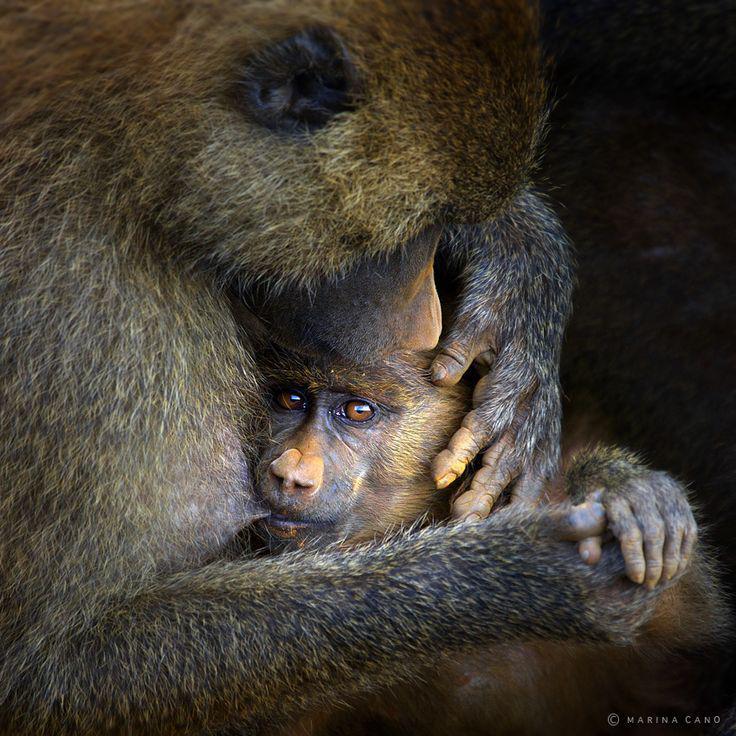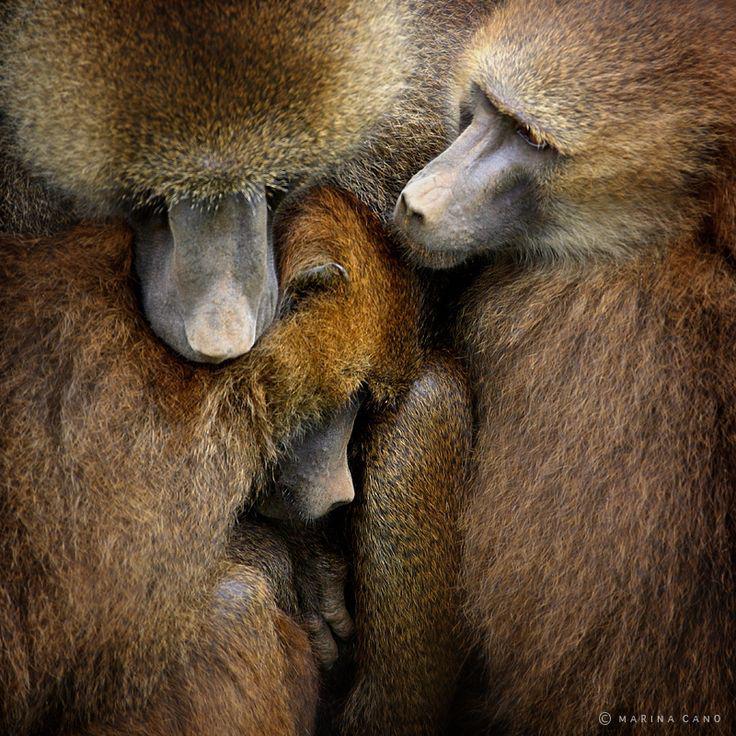The first image is the image on the left, the second image is the image on the right. Examine the images to the left and right. Is the description "At least one monkey has its mouth wide open with sharp teeth visible." accurate? Answer yes or no. No. The first image is the image on the left, the second image is the image on the right. Analyze the images presented: Is the assertion "An image includes a baboon baring its fangs with wide-opened mouth." valid? Answer yes or no. No. 